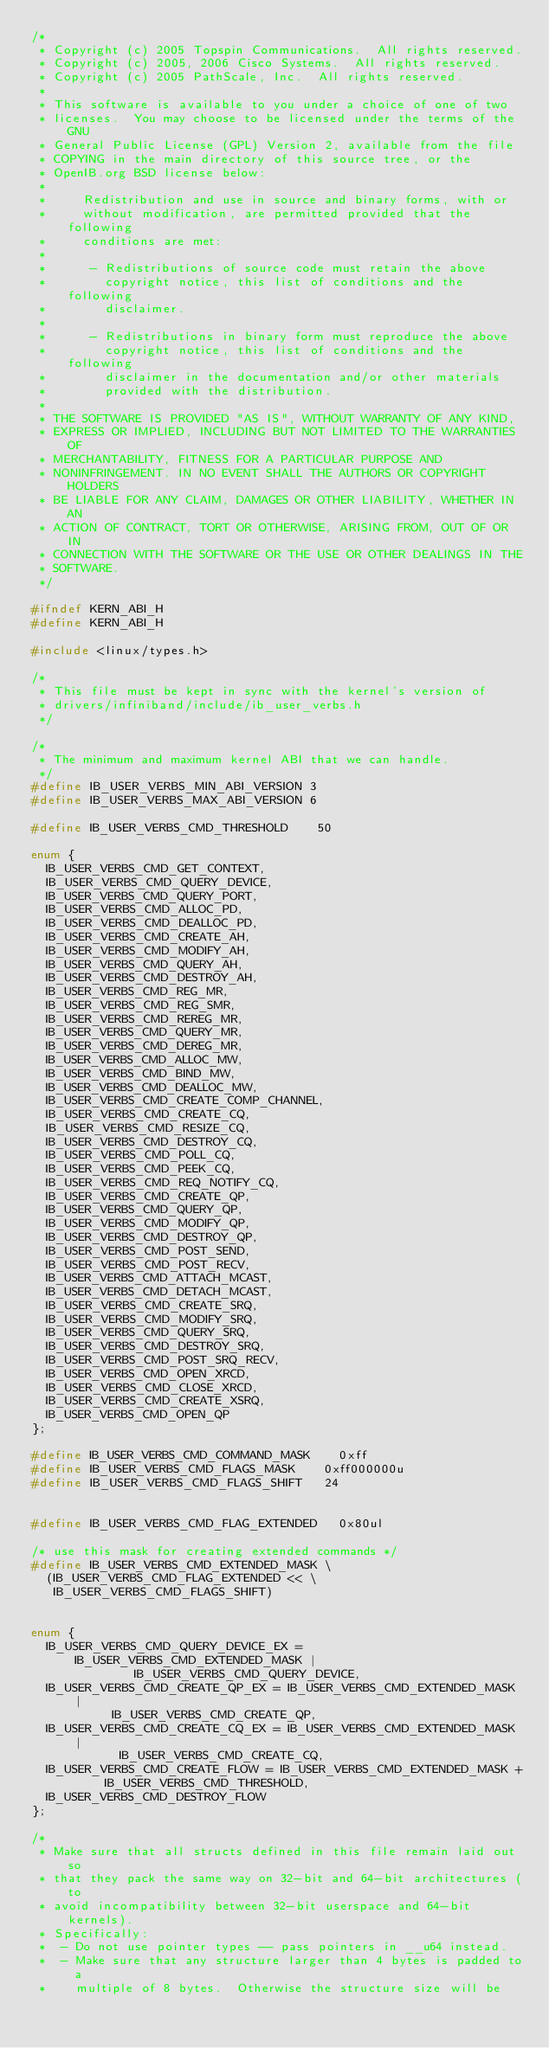<code> <loc_0><loc_0><loc_500><loc_500><_C_>/*
 * Copyright (c) 2005 Topspin Communications.  All rights reserved.
 * Copyright (c) 2005, 2006 Cisco Systems.  All rights reserved.
 * Copyright (c) 2005 PathScale, Inc.  All rights reserved.
 *
 * This software is available to you under a choice of one of two
 * licenses.  You may choose to be licensed under the terms of the GNU
 * General Public License (GPL) Version 2, available from the file
 * COPYING in the main directory of this source tree, or the
 * OpenIB.org BSD license below:
 *
 *     Redistribution and use in source and binary forms, with or
 *     without modification, are permitted provided that the following
 *     conditions are met:
 *
 *      - Redistributions of source code must retain the above
 *        copyright notice, this list of conditions and the following
 *        disclaimer.
 *
 *      - Redistributions in binary form must reproduce the above
 *        copyright notice, this list of conditions and the following
 *        disclaimer in the documentation and/or other materials
 *        provided with the distribution.
 *
 * THE SOFTWARE IS PROVIDED "AS IS", WITHOUT WARRANTY OF ANY KIND,
 * EXPRESS OR IMPLIED, INCLUDING BUT NOT LIMITED TO THE WARRANTIES OF
 * MERCHANTABILITY, FITNESS FOR A PARTICULAR PURPOSE AND
 * NONINFRINGEMENT. IN NO EVENT SHALL THE AUTHORS OR COPYRIGHT HOLDERS
 * BE LIABLE FOR ANY CLAIM, DAMAGES OR OTHER LIABILITY, WHETHER IN AN
 * ACTION OF CONTRACT, TORT OR OTHERWISE, ARISING FROM, OUT OF OR IN
 * CONNECTION WITH THE SOFTWARE OR THE USE OR OTHER DEALINGS IN THE
 * SOFTWARE.
 */

#ifndef KERN_ABI_H
#define KERN_ABI_H

#include <linux/types.h>

/*
 * This file must be kept in sync with the kernel's version of
 * drivers/infiniband/include/ib_user_verbs.h
 */

/*
 * The minimum and maximum kernel ABI that we can handle.
 */
#define IB_USER_VERBS_MIN_ABI_VERSION	3
#define IB_USER_VERBS_MAX_ABI_VERSION	6

#define IB_USER_VERBS_CMD_THRESHOLD    50

enum {
	IB_USER_VERBS_CMD_GET_CONTEXT,
	IB_USER_VERBS_CMD_QUERY_DEVICE,
	IB_USER_VERBS_CMD_QUERY_PORT,
	IB_USER_VERBS_CMD_ALLOC_PD,
	IB_USER_VERBS_CMD_DEALLOC_PD,
	IB_USER_VERBS_CMD_CREATE_AH,
	IB_USER_VERBS_CMD_MODIFY_AH,
	IB_USER_VERBS_CMD_QUERY_AH,
	IB_USER_VERBS_CMD_DESTROY_AH,
	IB_USER_VERBS_CMD_REG_MR,
	IB_USER_VERBS_CMD_REG_SMR,
	IB_USER_VERBS_CMD_REREG_MR,
	IB_USER_VERBS_CMD_QUERY_MR,
	IB_USER_VERBS_CMD_DEREG_MR,
	IB_USER_VERBS_CMD_ALLOC_MW,
	IB_USER_VERBS_CMD_BIND_MW,
	IB_USER_VERBS_CMD_DEALLOC_MW,
	IB_USER_VERBS_CMD_CREATE_COMP_CHANNEL,
	IB_USER_VERBS_CMD_CREATE_CQ,
	IB_USER_VERBS_CMD_RESIZE_CQ,
	IB_USER_VERBS_CMD_DESTROY_CQ,
	IB_USER_VERBS_CMD_POLL_CQ,
	IB_USER_VERBS_CMD_PEEK_CQ,
	IB_USER_VERBS_CMD_REQ_NOTIFY_CQ,
	IB_USER_VERBS_CMD_CREATE_QP,
	IB_USER_VERBS_CMD_QUERY_QP,
	IB_USER_VERBS_CMD_MODIFY_QP,
	IB_USER_VERBS_CMD_DESTROY_QP,
	IB_USER_VERBS_CMD_POST_SEND,
	IB_USER_VERBS_CMD_POST_RECV,
	IB_USER_VERBS_CMD_ATTACH_MCAST,
	IB_USER_VERBS_CMD_DETACH_MCAST,
	IB_USER_VERBS_CMD_CREATE_SRQ,
	IB_USER_VERBS_CMD_MODIFY_SRQ,
	IB_USER_VERBS_CMD_QUERY_SRQ,
	IB_USER_VERBS_CMD_DESTROY_SRQ,
	IB_USER_VERBS_CMD_POST_SRQ_RECV,
	IB_USER_VERBS_CMD_OPEN_XRCD,
	IB_USER_VERBS_CMD_CLOSE_XRCD,
	IB_USER_VERBS_CMD_CREATE_XSRQ,
	IB_USER_VERBS_CMD_OPEN_QP
};

#define IB_USER_VERBS_CMD_COMMAND_MASK		0xff
#define IB_USER_VERBS_CMD_FLAGS_MASK		0xff000000u
#define IB_USER_VERBS_CMD_FLAGS_SHIFT		24


#define IB_USER_VERBS_CMD_FLAG_EXTENDED		0x80ul

/* use this mask for creating extended commands */
#define IB_USER_VERBS_CMD_EXTENDED_MASK \
	(IB_USER_VERBS_CMD_FLAG_EXTENDED << \
	 IB_USER_VERBS_CMD_FLAGS_SHIFT)


enum {
	IB_USER_VERBS_CMD_QUERY_DEVICE_EX = IB_USER_VERBS_CMD_EXTENDED_MASK |
					    IB_USER_VERBS_CMD_QUERY_DEVICE,
	IB_USER_VERBS_CMD_CREATE_QP_EX = IB_USER_VERBS_CMD_EXTENDED_MASK |
					 IB_USER_VERBS_CMD_CREATE_QP,
	IB_USER_VERBS_CMD_CREATE_CQ_EX = IB_USER_VERBS_CMD_EXTENDED_MASK |
						IB_USER_VERBS_CMD_CREATE_CQ,
	IB_USER_VERBS_CMD_CREATE_FLOW = IB_USER_VERBS_CMD_EXTENDED_MASK +
					IB_USER_VERBS_CMD_THRESHOLD,
	IB_USER_VERBS_CMD_DESTROY_FLOW
};

/*
 * Make sure that all structs defined in this file remain laid out so
 * that they pack the same way on 32-bit and 64-bit architectures (to
 * avoid incompatibility between 32-bit userspace and 64-bit kernels).
 * Specifically:
 *  - Do not use pointer types -- pass pointers in __u64 instead.
 *  - Make sure that any structure larger than 4 bytes is padded to a
 *    multiple of 8 bytes.  Otherwise the structure size will be</code> 